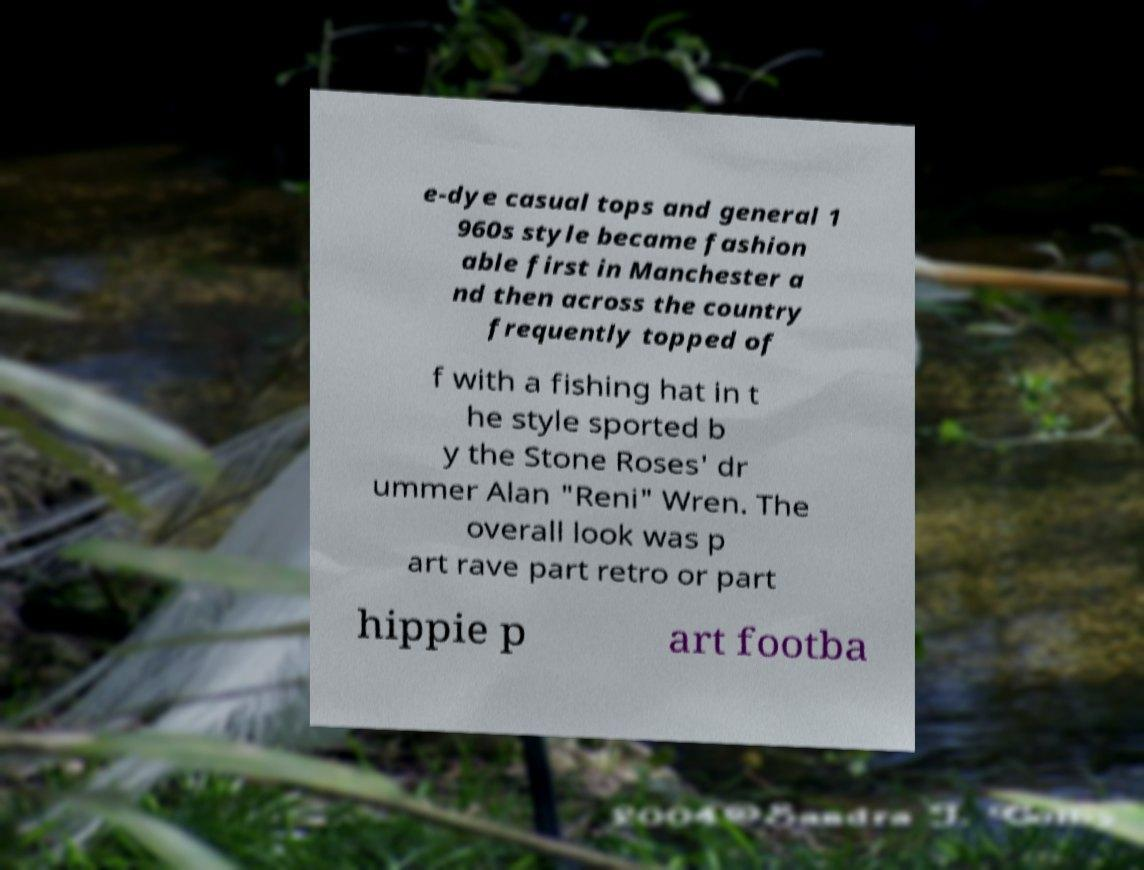Could you extract and type out the text from this image? e-dye casual tops and general 1 960s style became fashion able first in Manchester a nd then across the country frequently topped of f with a fishing hat in t he style sported b y the Stone Roses' dr ummer Alan "Reni" Wren. The overall look was p art rave part retro or part hippie p art footba 